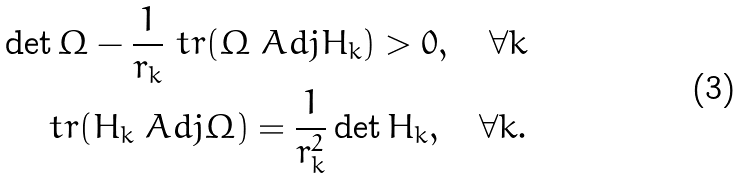Convert formula to latex. <formula><loc_0><loc_0><loc_500><loc_500>\det \Omega - \frac { 1 } { r _ { k } } \ t r ( \Omega \ A d j { H _ { k } } ) > 0 , \quad \forall k \\ \ t r ( H _ { k } \ A d j { \Omega } ) = \frac { 1 } { r _ { k } ^ { 2 } } \det H _ { k } , \quad \forall k .</formula> 